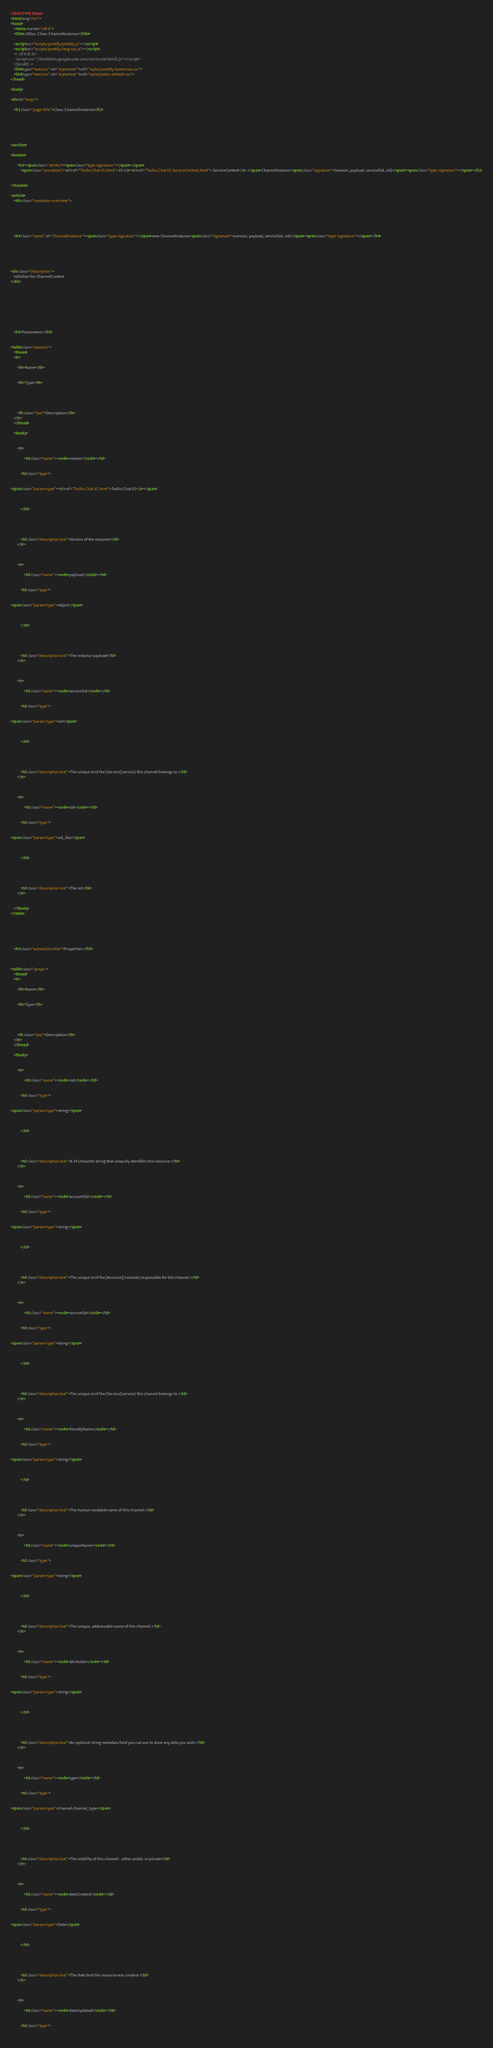<code> <loc_0><loc_0><loc_500><loc_500><_HTML_><!DOCTYPE html>
<html lang="en">
<head>
    <meta charset="utf-8">
    <title>JSDoc: Class: ChannelInstance</title>

    <script src="scripts/prettify/prettify.js"> </script>
    <script src="scripts/prettify/lang-css.js"> </script>
    <!--[if lt IE 9]>
      <script src="//html5shiv.googlecode.com/svn/trunk/html5.js"></script>
    <![endif]-->
    <link type="text/css" rel="stylesheet" href="styles/prettify-tomorrow.css">
    <link type="text/css" rel="stylesheet" href="styles/jsdoc-default.css">
</head>

<body>

<div id="main">

    <h1 class="page-title">Class: ChannelInstance</h1>

    




<section>

<header>
    
        <h2><span class="attribs"><span class="type-signature"></span></span>
            <span class="ancestors"><a href="Twilio.Chat.V1.html">.V1</a><a href="Twilio.Chat.V1.ServiceContext.html">.ServiceContext</a>.</span>ChannelInstance<span class="signature">(version, payload, serviceSid, sid)</span><span class="type-signature"></span></h2>
        
    
</header>

<article>
    <div class="container-overview">
    
        

    

    
    <h4 class="name" id="ChannelInstance"><span class="type-signature"></span>new ChannelInstance<span class="signature">(version, payload, serviceSid, sid)</span><span class="type-signature"></span></h4>
    

    



<div class="description">
    Initialize the ChannelContext
</div>









    <h5>Parameters:</h5>
    

<table class="params">
    <thead>
    <tr>
        
        <th>Name</th>
        

        <th>Type</th>

        

        

        <th class="last">Description</th>
    </tr>
    </thead>

    <tbody>
    

        <tr>
            
                <td class="name"><code>version</code></td>
            

            <td class="type">
            
                
<span class="param-type"><a href="Twilio.Chat.V1.html">Twilio.Chat.V1</a></span>


            
            </td>

            

            

            <td class="description last">Version of the resource</td>
        </tr>

    

        <tr>
            
                <td class="name"><code>payload</code></td>
            

            <td class="type">
            
                
<span class="param-type">object</span>


            
            </td>

            

            

            <td class="description last">The instance payload</td>
        </tr>

    

        <tr>
            
                <td class="name"><code>serviceSid</code></td>
            

            <td class="type">
            
                
<span class="param-type">sid</span>


            
            </td>

            

            

            <td class="description last">The unique id of the [Service][service] this channel belongs to.</td>
        </tr>

    

        <tr>
            
                <td class="name"><code>sid</code></td>
            

            <td class="type">
            
                
<span class="param-type">sid_like</span>


            
            </td>

            

            

            <td class="description last">The sid</td>
        </tr>

    
    </tbody>
</table>






    <h5 class="subsection-title">Properties:</h5>

    

<table class="props">
    <thead>
    <tr>
        
        <th>Name</th>
        

        <th>Type</th>

        

        

        <th class="last">Description</th>
    </tr>
    </thead>

    <tbody>
    

        <tr>
            
                <td class="name"><code>sid</code></td>
            

            <td class="type">
            
                
<span class="param-type">string</span>


            
            </td>

            

            

            <td class="description last">A 34 character string that uniquely identifies this resource.</td>
        </tr>

    

        <tr>
            
                <td class="name"><code>accountSid</code></td>
            

            <td class="type">
            
                
<span class="param-type">string</span>


            
            </td>

            

            

            <td class="description last">The unique id of the [Account][/console] responsible for this channel.</td>
        </tr>

    

        <tr>
            
                <td class="name"><code>serviceSid</code></td>
            

            <td class="type">
            
                
<span class="param-type">string</span>


            
            </td>

            

            

            <td class="description last">The unique id of the [Service][service] this channel belongs to.</td>
        </tr>

    

        <tr>
            
                <td class="name"><code>friendlyName</code></td>
            

            <td class="type">
            
                
<span class="param-type">string</span>


            
            </td>

            

            

            <td class="description last">The human-readable name of this channel.</td>
        </tr>

    

        <tr>
            
                <td class="name"><code>uniqueName</code></td>
            

            <td class="type">
            
                
<span class="param-type">string</span>


            
            </td>

            

            

            <td class="description last">The unique, addressable name of this channel.</td>
        </tr>

    

        <tr>
            
                <td class="name"><code>attributes</code></td>
            

            <td class="type">
            
                
<span class="param-type">string</span>


            
            </td>

            

            

            <td class="description last">An optional string metadata field you can use to store any data you wish.</td>
        </tr>

    

        <tr>
            
                <td class="name"><code>type</code></td>
            

            <td class="type">
            
                
<span class="param-type">channel.channel_type</span>


            
            </td>

            

            

            <td class="description last">The visibility of this channel - either public or private</td>
        </tr>

    

        <tr>
            
                <td class="name"><code>dateCreated</code></td>
            

            <td class="type">
            
                
<span class="param-type">Date</span>


            
            </td>

            

            

            <td class="description last">The date that this resource was created.</td>
        </tr>

    

        <tr>
            
                <td class="name"><code>dateUpdated</code></td>
            

            <td class="type">
            
                </code> 